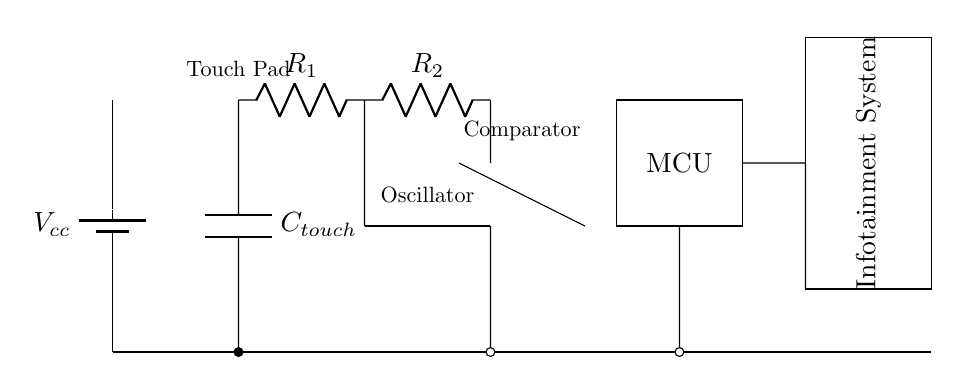What is the power supply voltage in this circuit? The power supply voltage is represented as Vcc, which is typically the source voltage for such circuits.
Answer: Vcc What components are present in the circuit? The circuit diagram includes a battery, a capacitive touch sensor, resistors, an oscillator, an operational amplifier (comparator), and a microcontroller. Each component is specifically labeled in the diagram.
Answer: Battery, capacitive touch sensor, resistors, oscillator, comparator, microcontroller What type of sensor is used in this circuit? The circuit uses a capacitive touch sensor, as indicated by the label next to the capacitor symbol in the diagram, which is specifically designed for detecting touch interactions.
Answer: Capacitive touch sensor How many resistors are in the circuit? There are two resistors (R1 and R2) present in the circuit, which are used to form a voltage divider and adjust the sensitivity of the capacitive touch sensor.
Answer: 2 What is the function of the oscillator in this circuit? The oscillator generates a specific signal frequency required for the capacitive touch sensing operation, allowing the sensor to detect changes in capacitance when touched.
Answer: Generate frequency How does the signal from the capacitive touch sensor reach the infotainment system? The signal from the capacitive touch sensor passes through resistors to the oscillator, then to the comparator, and finally to the microcontroller, which processes the input before sending it to the infotainment system.
Answer: Through the microcontroller What is the role of the comparator in the circuit? The comparator is used to compare the voltage level from the oscillator with a certain reference voltage to determine if a touch has been detected, thus triggering an output signal to the microcontroller.
Answer: Compare voltages 